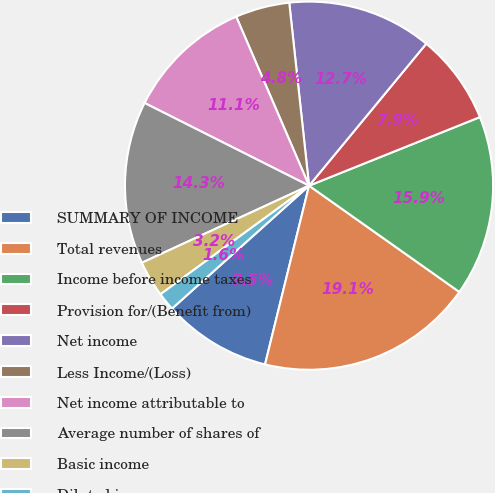Convert chart to OTSL. <chart><loc_0><loc_0><loc_500><loc_500><pie_chart><fcel>SUMMARY OF INCOME<fcel>Total revenues<fcel>Income before income taxes<fcel>Provision for/(Benefit from)<fcel>Net income<fcel>Less Income/(Loss)<fcel>Net income attributable to<fcel>Average number of shares of<fcel>Basic income<fcel>Diluted income<nl><fcel>9.52%<fcel>19.05%<fcel>15.87%<fcel>7.94%<fcel>12.7%<fcel>4.76%<fcel>11.11%<fcel>14.29%<fcel>3.17%<fcel>1.59%<nl></chart> 